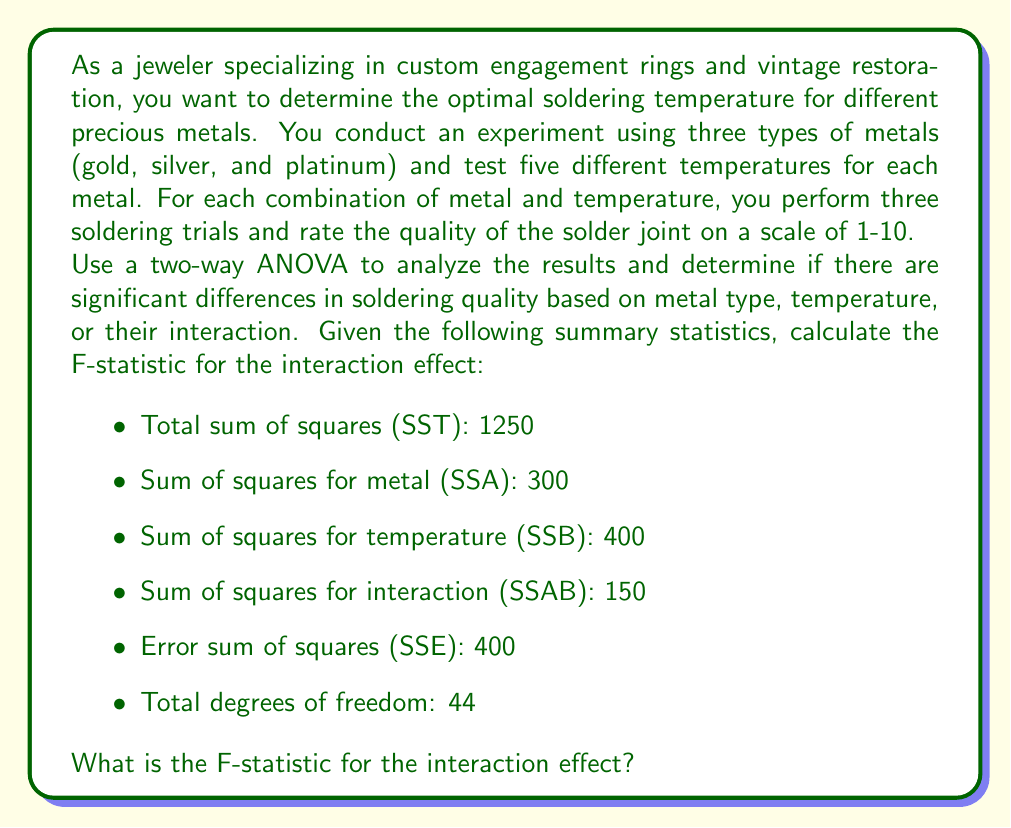Show me your answer to this math problem. To solve this problem, we need to follow these steps:

1. Identify the degrees of freedom for each source of variation:
   - Metal (Factor A): $df_A = a - 1 = 3 - 1 = 2$
   - Temperature (Factor B): $df_B = b - 1 = 5 - 1 = 4$
   - Interaction (AB): $df_{AB} = (a-1)(b-1) = 2 \times 4 = 8$
   - Error: $df_E = \text{Total df} - df_A - df_B - df_{AB} = 44 - 2 - 4 - 8 = 30$

2. Calculate the mean square for the interaction effect:
   $$MS_{AB} = \frac{SS_{AB}}{df_{AB}} = \frac{150}{8} = 18.75$$

3. Calculate the mean square for error:
   $$MS_E = \frac{SS_E}{df_E} = \frac{400}{30} = 13.33$$

4. Calculate the F-statistic for the interaction effect:
   $$F_{AB} = \frac{MS_{AB}}{MS_E} = \frac{18.75}{13.33} = 1.41$$

The F-statistic for the interaction effect is the ratio of the mean square for interaction to the mean square for error. This value allows us to determine if there is a significant interaction effect between metal type and temperature on soldering quality.
Answer: The F-statistic for the interaction effect is 1.41. 